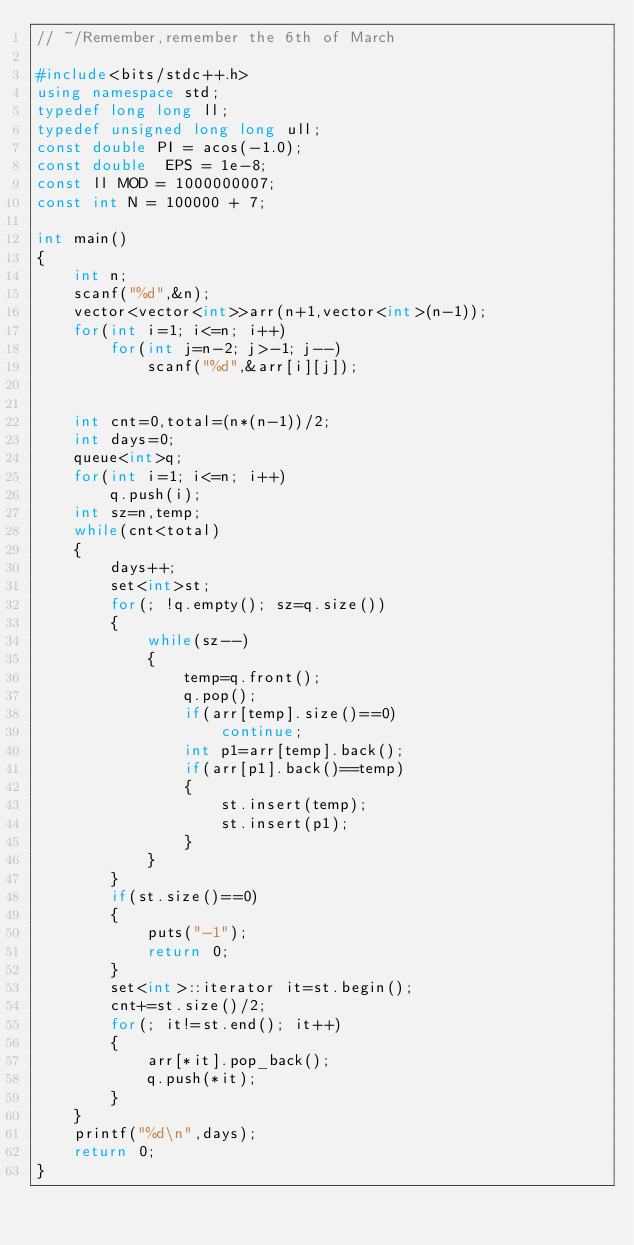<code> <loc_0><loc_0><loc_500><loc_500><_C++_>// ~/Remember,remember the 6th of March

#include<bits/stdc++.h>
using namespace std;
typedef long long ll;
typedef unsigned long long ull;
const double PI = acos(-1.0);
const double  EPS = 1e-8;
const ll MOD = 1000000007;
const int N = 100000 + 7;

int main()
{
    int n;
    scanf("%d",&n);
    vector<vector<int>>arr(n+1,vector<int>(n-1));
    for(int i=1; i<=n; i++)
        for(int j=n-2; j>-1; j--)
            scanf("%d",&arr[i][j]);


    int cnt=0,total=(n*(n-1))/2;
    int days=0;
    queue<int>q;
    for(int i=1; i<=n; i++)
        q.push(i);
    int sz=n,temp;
    while(cnt<total)
    {
        days++;
        set<int>st;
        for(; !q.empty(); sz=q.size())
        {
            while(sz--)
            {
                temp=q.front();
                q.pop();
                if(arr[temp].size()==0)
                    continue;
                int p1=arr[temp].back();
                if(arr[p1].back()==temp)
                {
                    st.insert(temp);
                    st.insert(p1);
                }
            }
        }
        if(st.size()==0)
        {
            puts("-1");
            return 0;
        }
        set<int>::iterator it=st.begin();
        cnt+=st.size()/2;
        for(; it!=st.end(); it++)
        {
            arr[*it].pop_back();
            q.push(*it);
        }
    }
    printf("%d\n",days);
    return 0;
}
</code> 